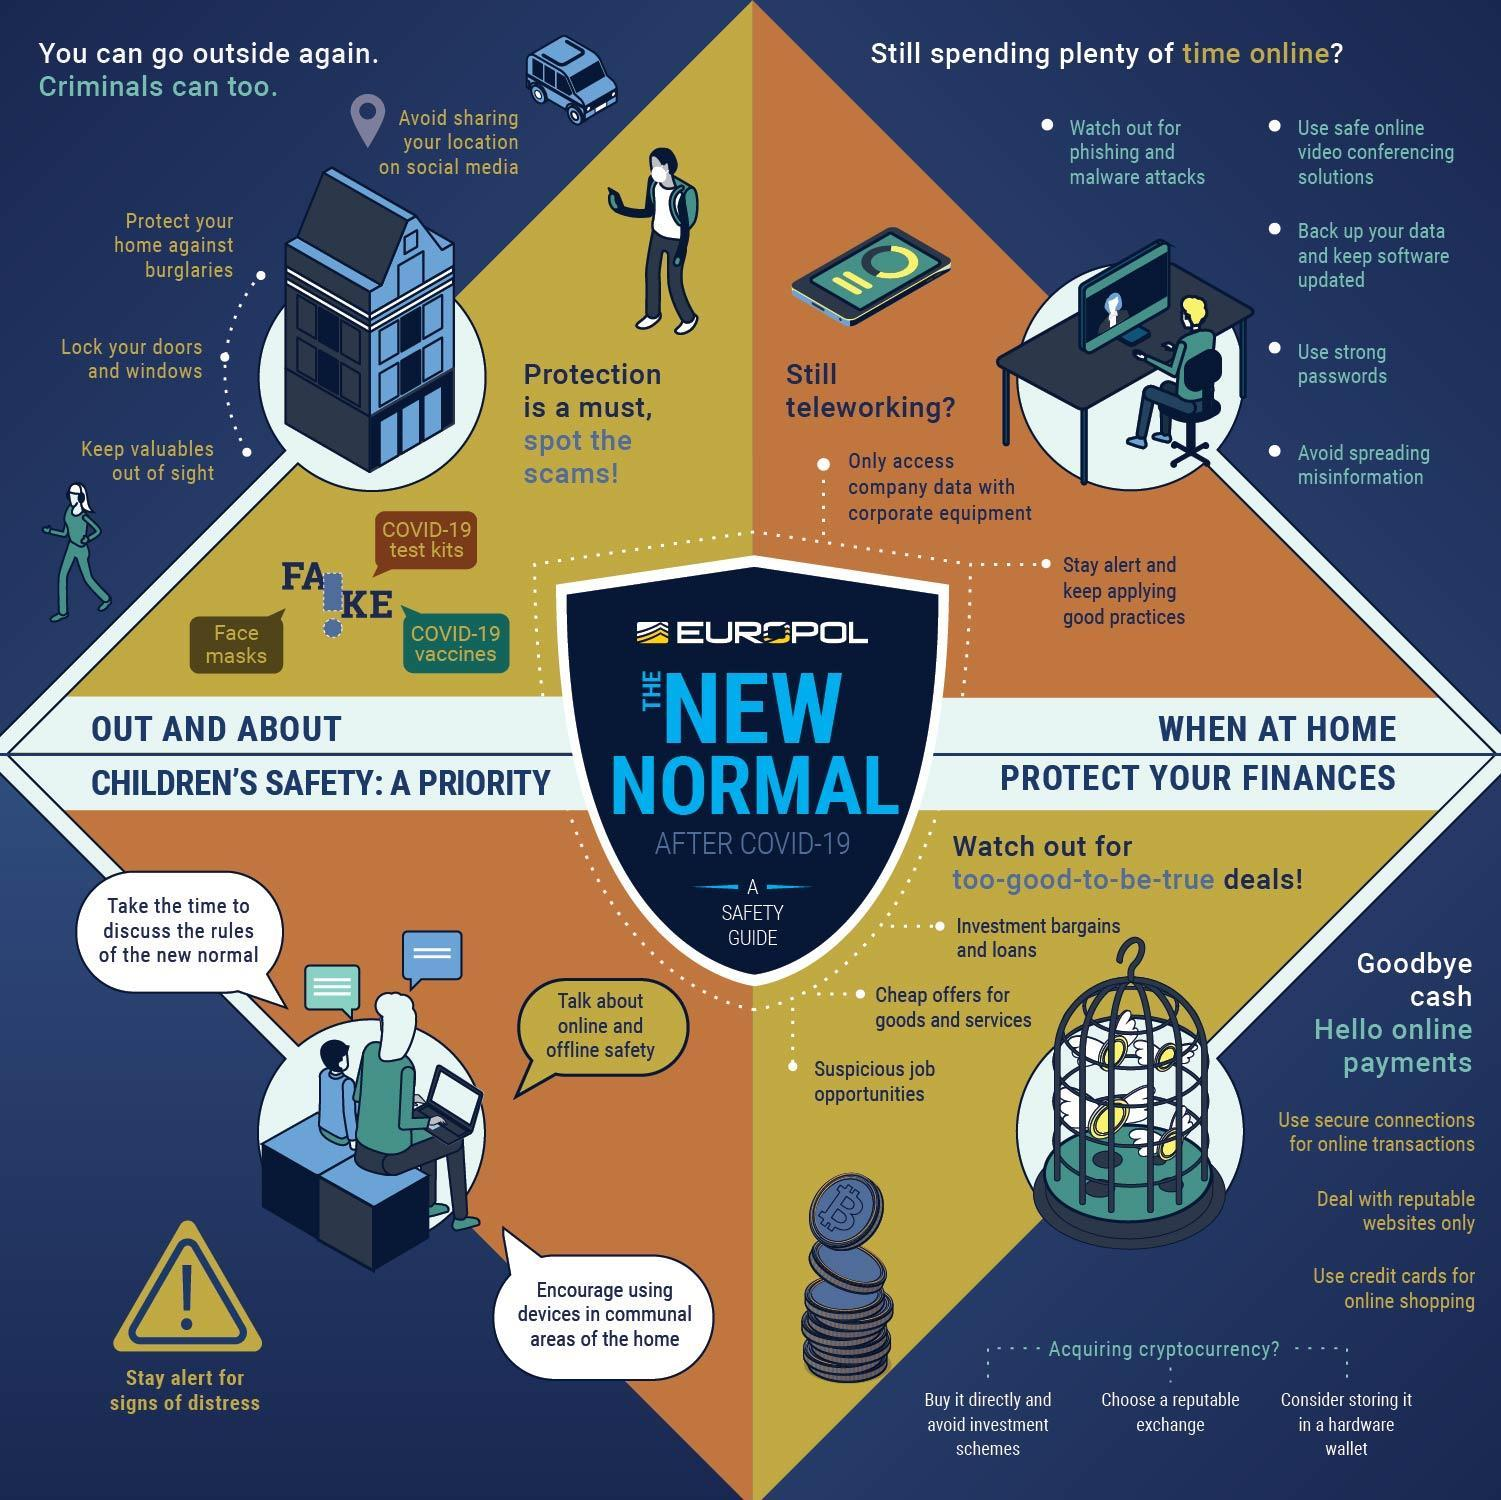What is the third point to be taken care of while moving out of home?
Answer the question with a short phrase. lock you doors and windows What kind of web pages are to be selected while doing online activities? reputable websites What needs to be taken care of while doing transactions through the internet? use secure connections How many gears against corona are listed in the infographic which is fake? 3 What is the fourth point to be taken care of while doing activities online? Use strong passwords What kind of money transactions is the best during or after a pandemic? online payments What needs to be taken care of while working with office gadgets? only access company data with corporate equipment Which is the best method to make payment while purchasing online? use credit cards for online shopping How many safety measures for kids are shown in the infographic? 3 